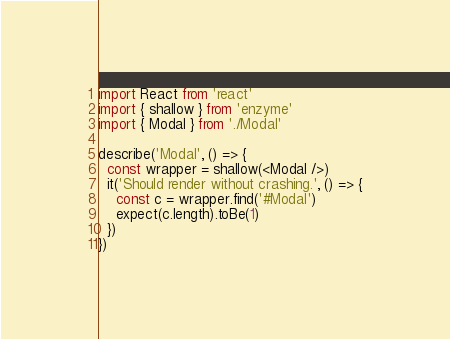Convert code to text. <code><loc_0><loc_0><loc_500><loc_500><_TypeScript_>import React from 'react'
import { shallow } from 'enzyme'
import { Modal } from './Modal'

describe('Modal', () => {
  const wrapper = shallow(<Modal />)
  it('Should render without crashing.', () => {
    const c = wrapper.find('#Modal')
    expect(c.length).toBe(1)
  })
})
</code> 